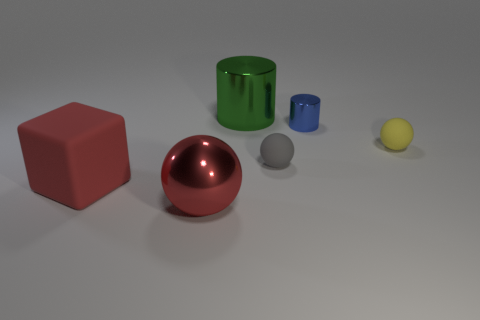What number of blue cylinders are left of the big object on the right side of the large red metal object?
Keep it short and to the point. 0. What number of objects are either things behind the big red shiny object or large cylinders?
Give a very brief answer. 5. How many large green cylinders are made of the same material as the red cube?
Your answer should be compact. 0. What shape is the big thing that is the same color as the large metal sphere?
Offer a terse response. Cube. Are there an equal number of big red cubes that are behind the big green shiny cylinder and large red balls?
Make the answer very short. No. There is a metallic object left of the green shiny cylinder; what is its size?
Your response must be concise. Large. How many tiny objects are brown rubber cubes or blue metal cylinders?
Make the answer very short. 1. The shiny object that is the same shape as the gray matte object is what color?
Provide a succinct answer. Red. Is the size of the red block the same as the yellow sphere?
Ensure brevity in your answer.  No. How many objects are large purple shiny things or balls on the right side of the metal sphere?
Provide a short and direct response. 2. 